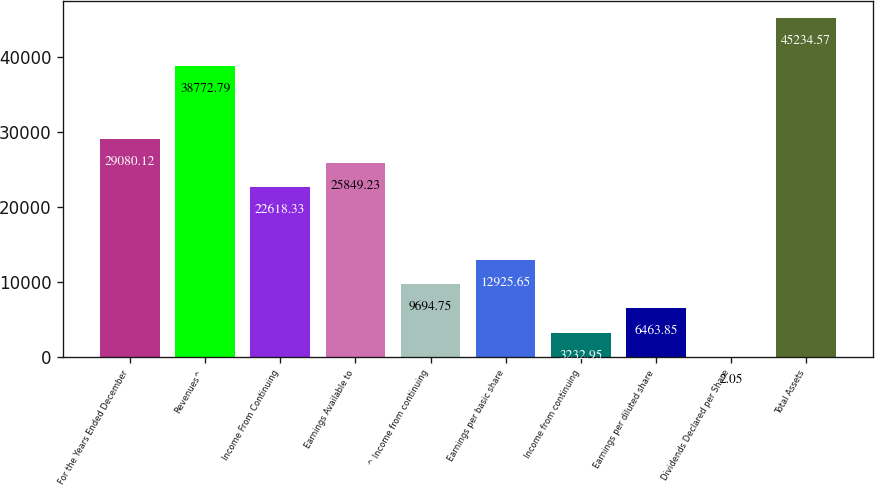<chart> <loc_0><loc_0><loc_500><loc_500><bar_chart><fcel>For the Years Ended December<fcel>Revenues^<fcel>Income From Continuing<fcel>Earnings Available to<fcel>^ Income from continuing<fcel>Earnings per basic share<fcel>Income from continuing<fcel>Earnings per diluted share<fcel>Dividends Declared per Share<fcel>Total Assets<nl><fcel>29080.1<fcel>38772.8<fcel>22618.3<fcel>25849.2<fcel>9694.75<fcel>12925.6<fcel>3232.95<fcel>6463.85<fcel>2.05<fcel>45234.6<nl></chart> 